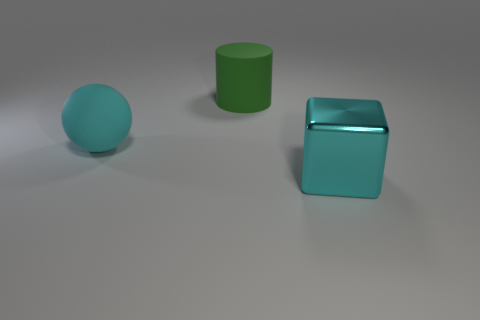Add 2 large green cylinders. How many objects exist? 5 Subtract all cylinders. How many objects are left? 2 Subtract 0 red cylinders. How many objects are left? 3 Subtract all small blue metal objects. Subtract all large rubber cylinders. How many objects are left? 2 Add 1 shiny things. How many shiny things are left? 2 Add 3 small purple cylinders. How many small purple cylinders exist? 3 